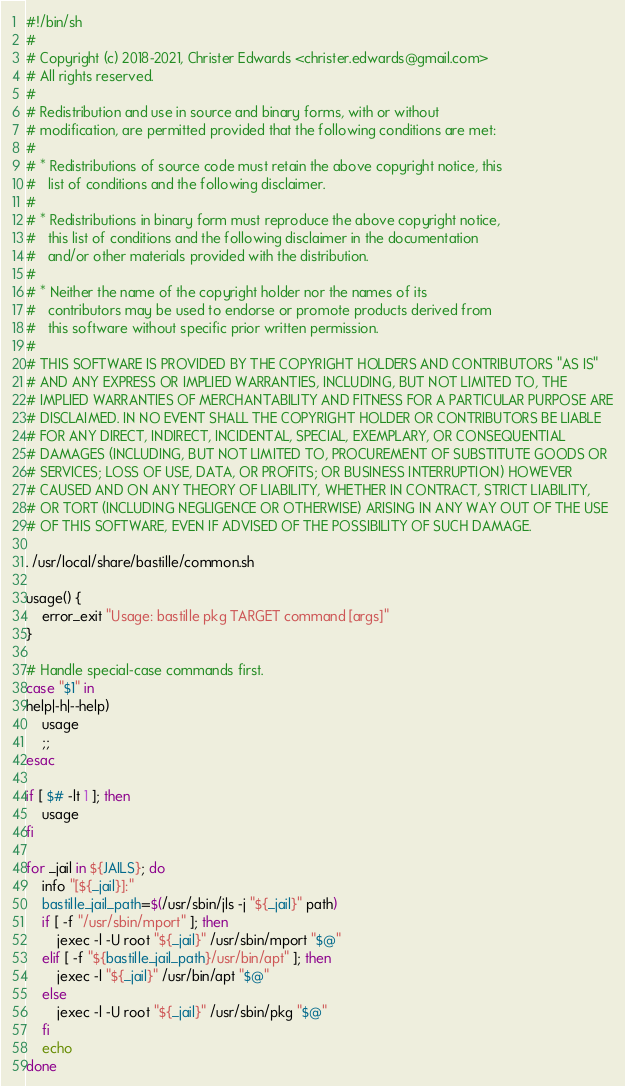Convert code to text. <code><loc_0><loc_0><loc_500><loc_500><_Bash_>#!/bin/sh
#
# Copyright (c) 2018-2021, Christer Edwards <christer.edwards@gmail.com>
# All rights reserved.
#
# Redistribution and use in source and binary forms, with or without
# modification, are permitted provided that the following conditions are met:
#
# * Redistributions of source code must retain the above copyright notice, this
#   list of conditions and the following disclaimer.
#
# * Redistributions in binary form must reproduce the above copyright notice,
#   this list of conditions and the following disclaimer in the documentation
#   and/or other materials provided with the distribution.
#
# * Neither the name of the copyright holder nor the names of its
#   contributors may be used to endorse or promote products derived from
#   this software without specific prior written permission.
#
# THIS SOFTWARE IS PROVIDED BY THE COPYRIGHT HOLDERS AND CONTRIBUTORS "AS IS"
# AND ANY EXPRESS OR IMPLIED WARRANTIES, INCLUDING, BUT NOT LIMITED TO, THE
# IMPLIED WARRANTIES OF MERCHANTABILITY AND FITNESS FOR A PARTICULAR PURPOSE ARE
# DISCLAIMED. IN NO EVENT SHALL THE COPYRIGHT HOLDER OR CONTRIBUTORS BE LIABLE
# FOR ANY DIRECT, INDIRECT, INCIDENTAL, SPECIAL, EXEMPLARY, OR CONSEQUENTIAL
# DAMAGES (INCLUDING, BUT NOT LIMITED TO, PROCUREMENT OF SUBSTITUTE GOODS OR
# SERVICES; LOSS OF USE, DATA, OR PROFITS; OR BUSINESS INTERRUPTION) HOWEVER
# CAUSED AND ON ANY THEORY OF LIABILITY, WHETHER IN CONTRACT, STRICT LIABILITY,
# OR TORT (INCLUDING NEGLIGENCE OR OTHERWISE) ARISING IN ANY WAY OUT OF THE USE
# OF THIS SOFTWARE, EVEN IF ADVISED OF THE POSSIBILITY OF SUCH DAMAGE.

. /usr/local/share/bastille/common.sh

usage() {
    error_exit "Usage: bastille pkg TARGET command [args]"
}

# Handle special-case commands first.
case "$1" in
help|-h|--help)
    usage
    ;;
esac

if [ $# -lt 1 ]; then
    usage
fi

for _jail in ${JAILS}; do
    info "[${_jail}]:"
    bastille_jail_path=$(/usr/sbin/jls -j "${_jail}" path)
    if [ -f "/usr/sbin/mport" ]; then
        jexec -l -U root "${_jail}" /usr/sbin/mport "$@"
    elif [ -f "${bastille_jail_path}/usr/bin/apt" ]; then
        jexec -l "${_jail}" /usr/bin/apt "$@"
    else
        jexec -l -U root "${_jail}" /usr/sbin/pkg "$@"
    fi
    echo
done
</code> 